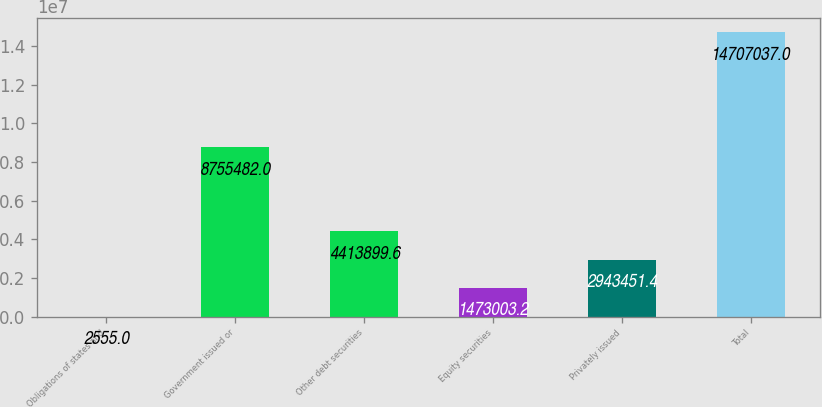Convert chart to OTSL. <chart><loc_0><loc_0><loc_500><loc_500><bar_chart><fcel>Obligations of states and<fcel>Government issued or<fcel>Other debt securities<fcel>Equity securities<fcel>Privately issued<fcel>Total<nl><fcel>2555<fcel>8.75548e+06<fcel>4.4139e+06<fcel>1.473e+06<fcel>2.94345e+06<fcel>1.4707e+07<nl></chart> 